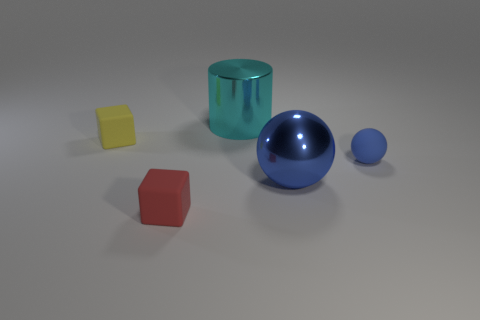Add 1 green things. How many objects exist? 6 Subtract all red blocks. How many blocks are left? 1 Subtract all big cyan balls. Subtract all metal spheres. How many objects are left? 4 Add 3 yellow things. How many yellow things are left? 4 Add 5 small blue matte spheres. How many small blue matte spheres exist? 6 Subtract 0 cyan blocks. How many objects are left? 5 Subtract all cylinders. How many objects are left? 4 